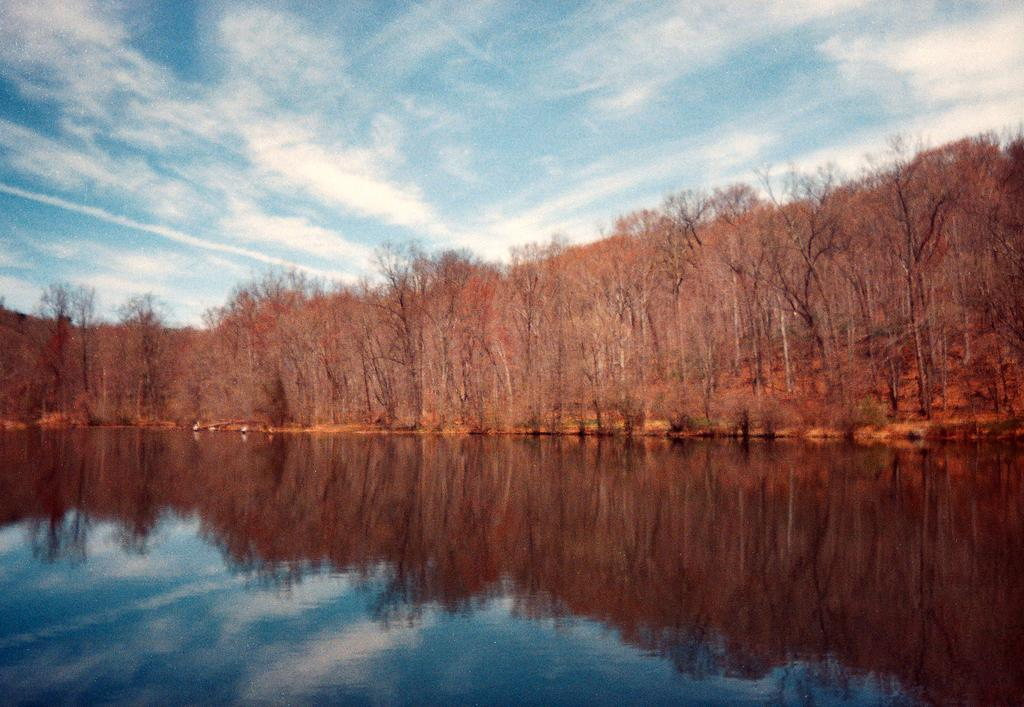What is present in the picture? There is water and trees in the picture. What can be seen in the background of the picture? The sky is visible in the background of the picture. What is the cause of the bridge collapsing in the image? There is no bridge present in the image, so it is not possible to determine the cause of any collapse. 